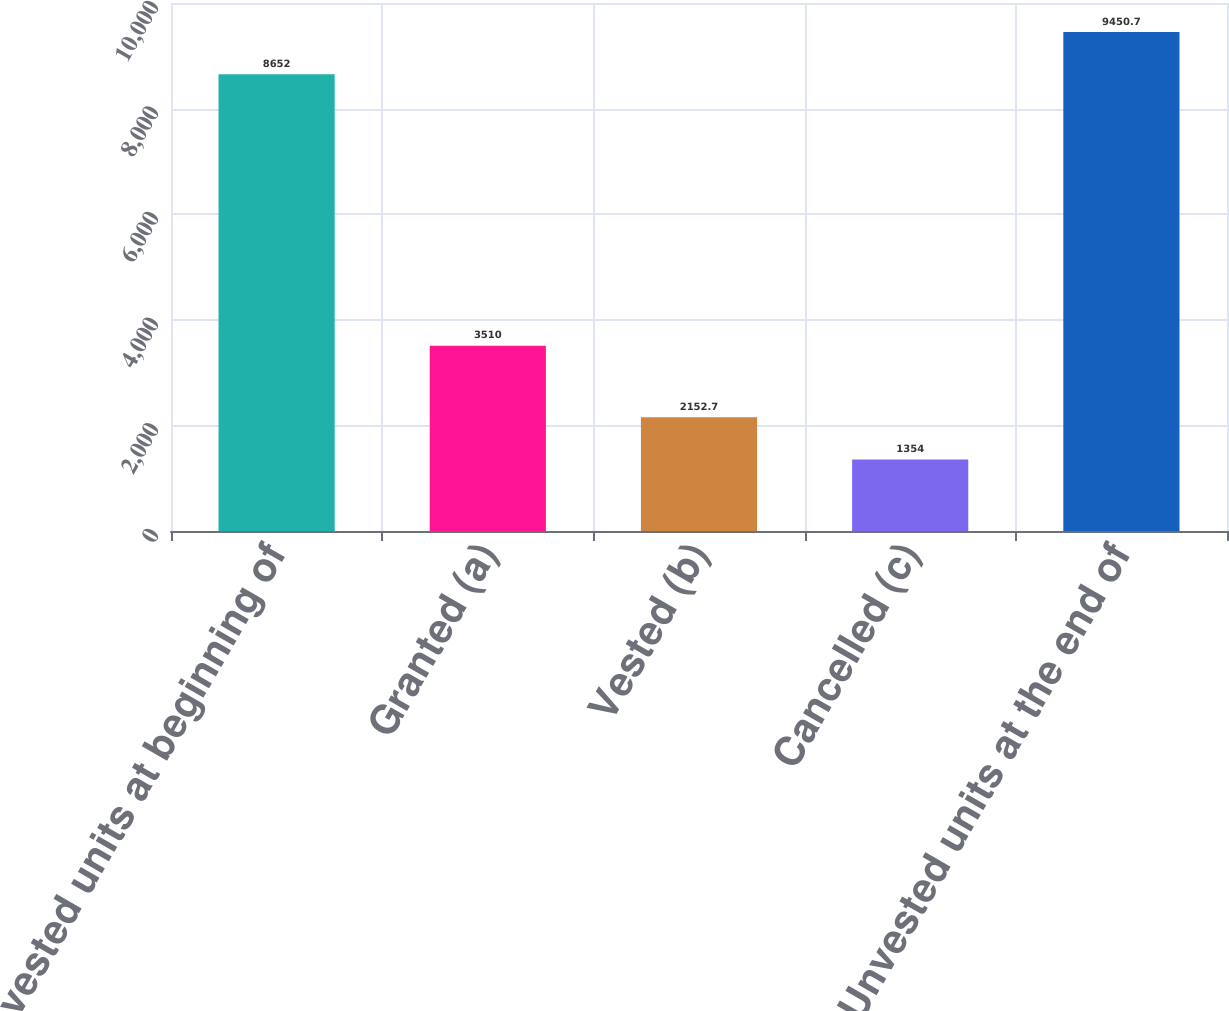Convert chart to OTSL. <chart><loc_0><loc_0><loc_500><loc_500><bar_chart><fcel>Unvested units at beginning of<fcel>Granted (a)<fcel>Vested (b)<fcel>Cancelled (c)<fcel>Unvested units at the end of<nl><fcel>8652<fcel>3510<fcel>2152.7<fcel>1354<fcel>9450.7<nl></chart> 